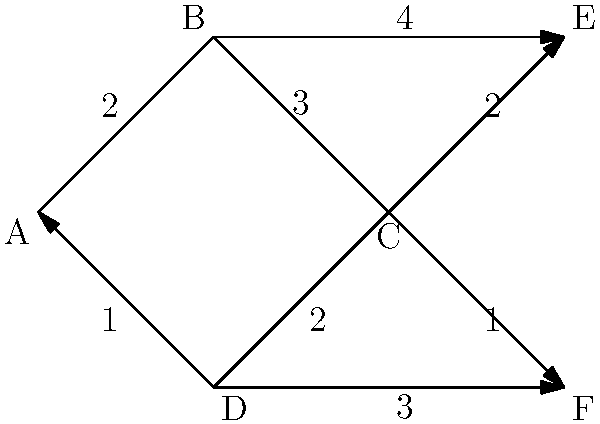In this network topology diagram, each edge represents a communication link with its associated cost. What is the most efficient routing path from node A to node E, and what is its total cost? To find the most efficient routing path from node A to node E, we need to consider all possible paths and their total costs. Let's break it down step-by-step:

1. Identify all possible paths from A to E:
   - Path 1: A → B → E
   - Path 2: A → B → C → E
   - Path 3: A → D → C → E

2. Calculate the cost for each path:
   - Path 1: A → B → E
     Cost = 2 + 4 = 6

   - Path 2: A → B → C → E
     Cost = 2 + 3 + 2 = 7

   - Path 3: A → D → C → E
     Cost = 1 + 2 + 2 = 5

3. Compare the costs:
   Path 1: 6
   Path 2: 7
   Path 3: 5

4. Identify the path with the lowest cost:
   Path 3 (A → D → C → E) has the lowest cost of 5.

Therefore, the most efficient routing path from node A to node E is A → D → C → E, with a total cost of 5.
Answer: A → D → C → E, cost 5 